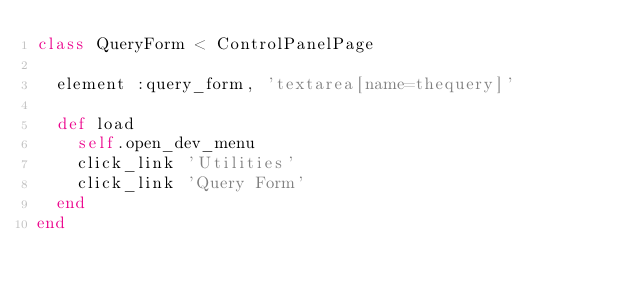Convert code to text. <code><loc_0><loc_0><loc_500><loc_500><_Ruby_>class QueryForm < ControlPanelPage

  element :query_form, 'textarea[name=thequery]'

  def load
    self.open_dev_menu
    click_link 'Utilities'
    click_link 'Query Form'
  end
end
</code> 